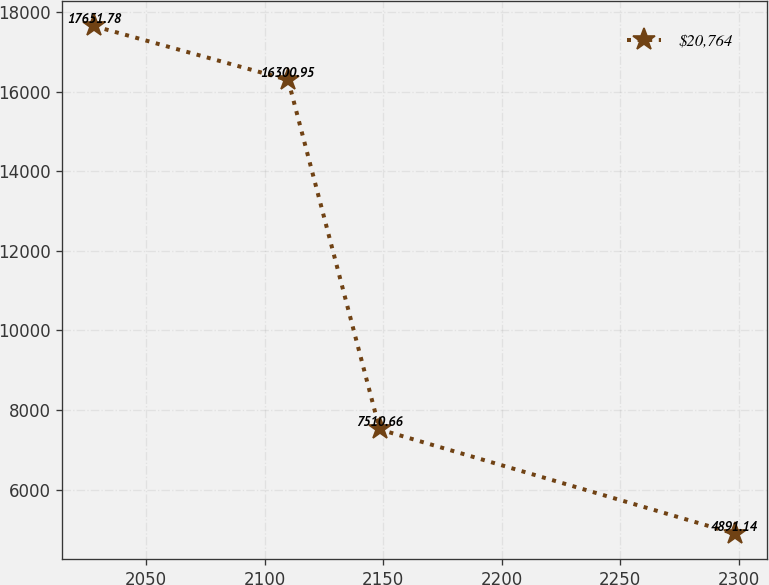Convert chart to OTSL. <chart><loc_0><loc_0><loc_500><loc_500><line_chart><ecel><fcel>$20,764<nl><fcel>2028.26<fcel>17651.8<nl><fcel>2109.94<fcel>16301<nl><fcel>2148.54<fcel>7510.66<nl><fcel>2298.2<fcel>4891.14<nl></chart> 